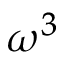Convert formula to latex. <formula><loc_0><loc_0><loc_500><loc_500>\omega ^ { 3 }</formula> 